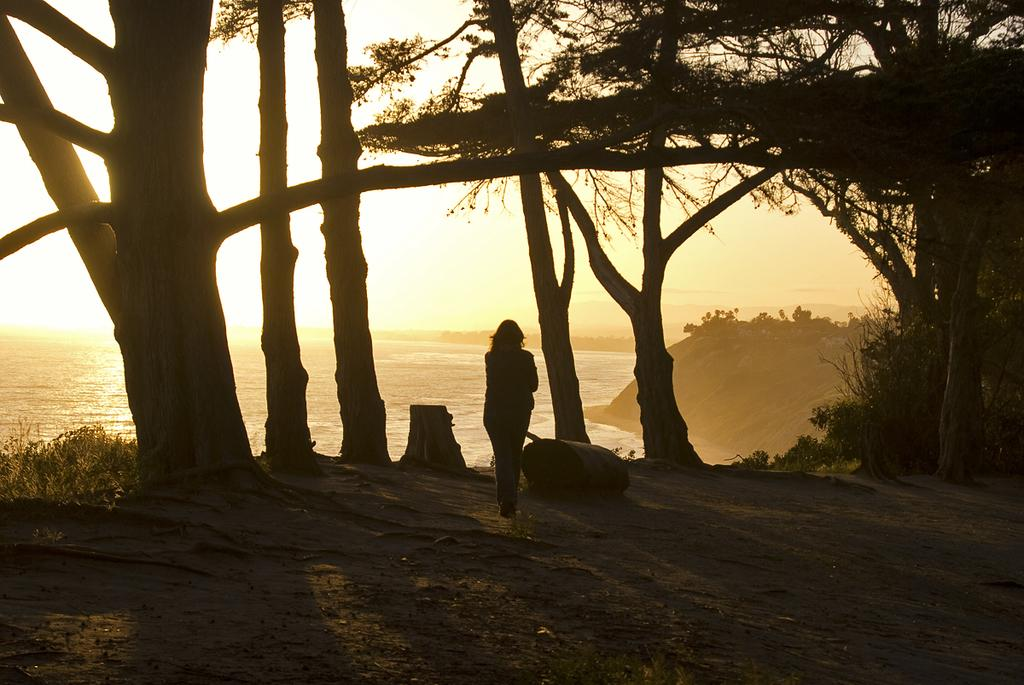What is the main subject of the image? There is a person standing in the image. What is the person doing in the image? The person is looking at something. What type of natural environment is visible in the image? There are trees and water visible in the image. What is visible in the background of the image? The sky is visible in the background of the image. What type of wire is being sold at the market in the image? There is no market or wire present in the image; it features a person standing and looking at something in a natural environment. What type of base is supporting the trees in the image? There is no base visible in the image; the trees are growing naturally in the environment. 